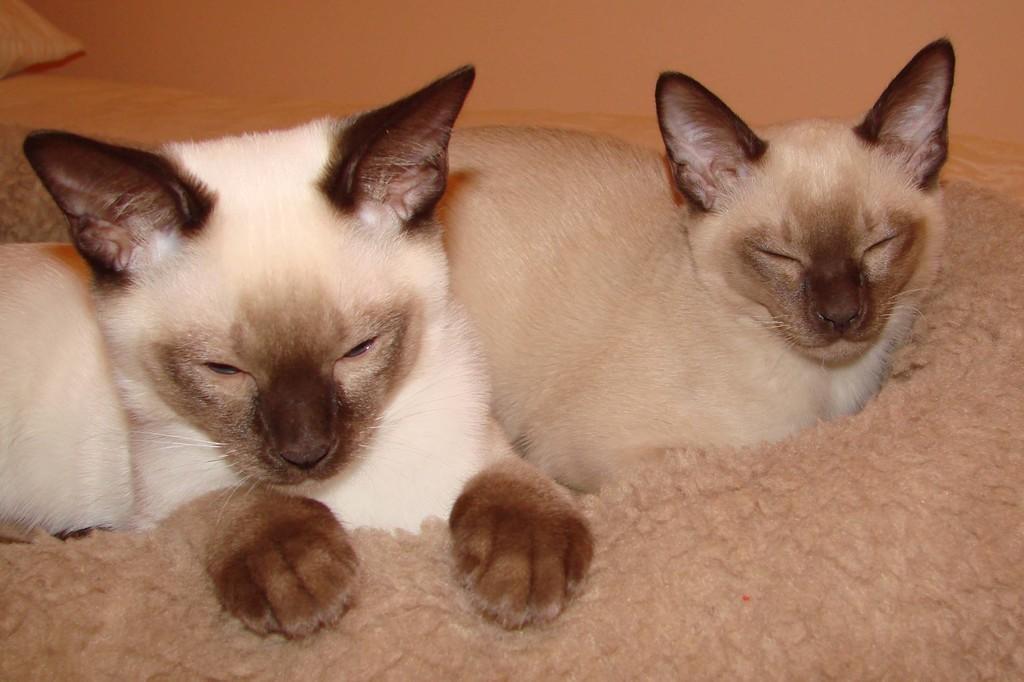Can you describe this image briefly? In this image I can see there are cats on the bed. And there is a pillow and a cloth. And at the back there is a wall. 